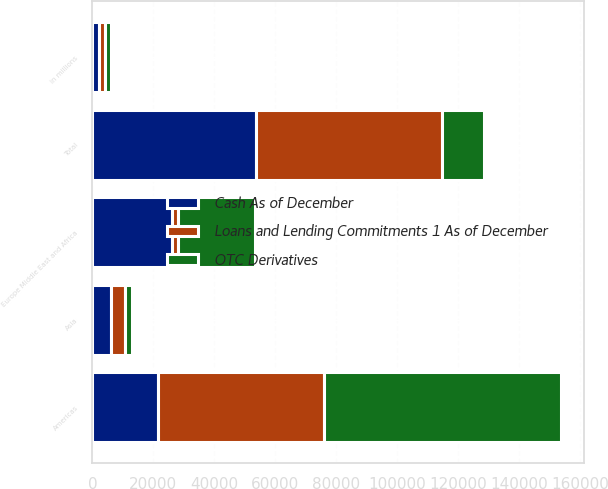Convert chart. <chart><loc_0><loc_0><loc_500><loc_500><stacked_bar_chart><ecel><fcel>in millions<fcel>Americas<fcel>Europe Middle East and Africa<fcel>Asia<fcel>Total<nl><fcel>Loans and Lending Commitments 1 As of December<fcel>2013<fcel>54470<fcel>2143<fcel>4520<fcel>61133<nl><fcel>Cash As of December<fcel>2013<fcel>21423<fcel>25983<fcel>6196<fcel>53602<nl><fcel>OTC Derivatives<fcel>2013<fcel>77710<fcel>25222<fcel>2393<fcel>13809.5<nl></chart> 